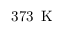<formula> <loc_0><loc_0><loc_500><loc_500>3 7 3 \, K</formula> 